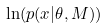<formula> <loc_0><loc_0><loc_500><loc_500>\ln ( p ( x | \theta , M ) )</formula> 